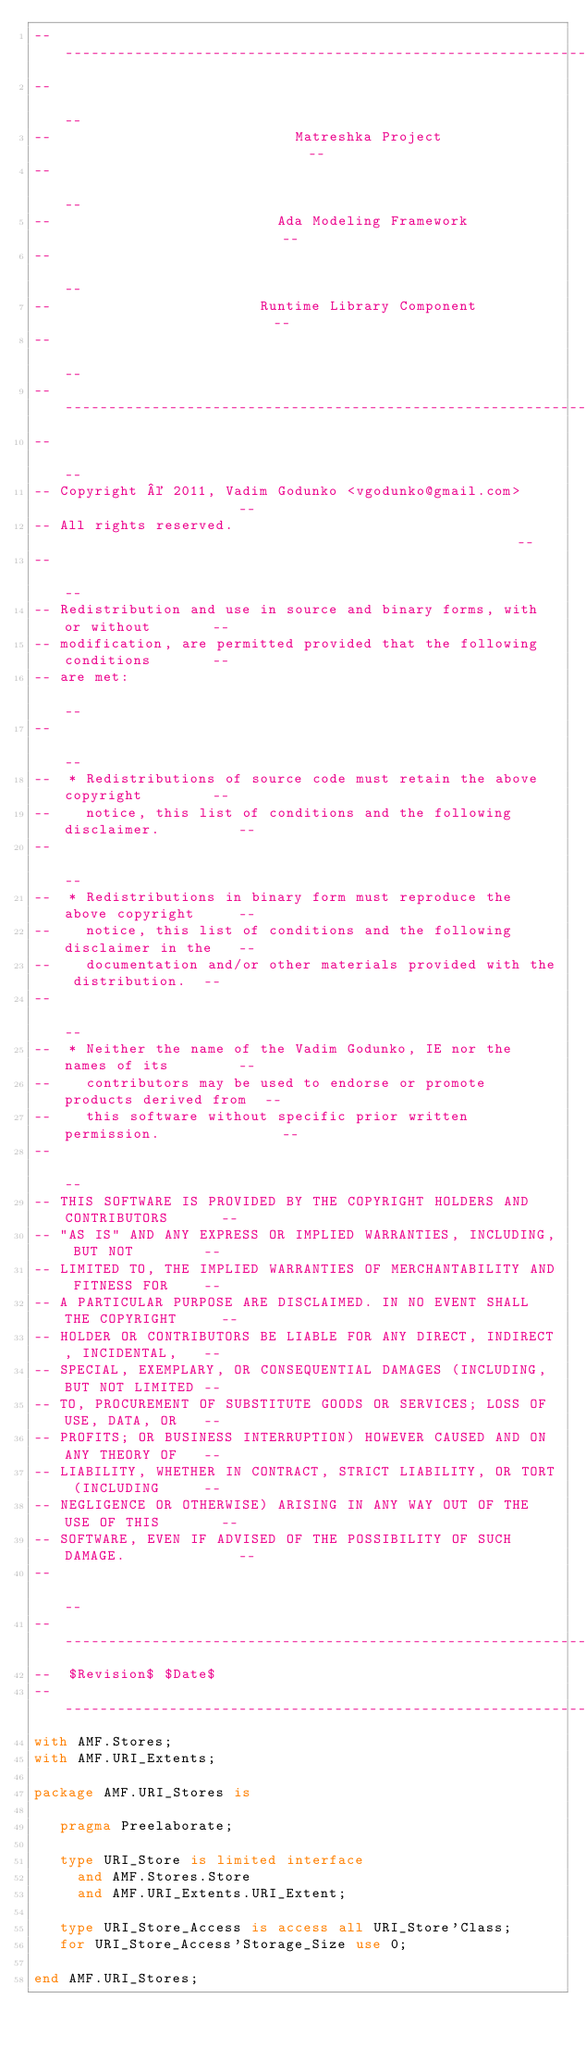Convert code to text. <code><loc_0><loc_0><loc_500><loc_500><_Ada_>------------------------------------------------------------------------------
--                                                                          --
--                            Matreshka Project                             --
--                                                                          --
--                          Ada Modeling Framework                          --
--                                                                          --
--                        Runtime Library Component                         --
--                                                                          --
------------------------------------------------------------------------------
--                                                                          --
-- Copyright © 2011, Vadim Godunko <vgodunko@gmail.com>                     --
-- All rights reserved.                                                     --
--                                                                          --
-- Redistribution and use in source and binary forms, with or without       --
-- modification, are permitted provided that the following conditions       --
-- are met:                                                                 --
--                                                                          --
--  * Redistributions of source code must retain the above copyright        --
--    notice, this list of conditions and the following disclaimer.         --
--                                                                          --
--  * Redistributions in binary form must reproduce the above copyright     --
--    notice, this list of conditions and the following disclaimer in the   --
--    documentation and/or other materials provided with the distribution.  --
--                                                                          --
--  * Neither the name of the Vadim Godunko, IE nor the names of its        --
--    contributors may be used to endorse or promote products derived from  --
--    this software without specific prior written permission.              --
--                                                                          --
-- THIS SOFTWARE IS PROVIDED BY THE COPYRIGHT HOLDERS AND CONTRIBUTORS      --
-- "AS IS" AND ANY EXPRESS OR IMPLIED WARRANTIES, INCLUDING, BUT NOT        --
-- LIMITED TO, THE IMPLIED WARRANTIES OF MERCHANTABILITY AND FITNESS FOR    --
-- A PARTICULAR PURPOSE ARE DISCLAIMED. IN NO EVENT SHALL THE COPYRIGHT     --
-- HOLDER OR CONTRIBUTORS BE LIABLE FOR ANY DIRECT, INDIRECT, INCIDENTAL,   --
-- SPECIAL, EXEMPLARY, OR CONSEQUENTIAL DAMAGES (INCLUDING, BUT NOT LIMITED --
-- TO, PROCUREMENT OF SUBSTITUTE GOODS OR SERVICES; LOSS OF USE, DATA, OR   --
-- PROFITS; OR BUSINESS INTERRUPTION) HOWEVER CAUSED AND ON ANY THEORY OF   --
-- LIABILITY, WHETHER IN CONTRACT, STRICT LIABILITY, OR TORT (INCLUDING     --
-- NEGLIGENCE OR OTHERWISE) ARISING IN ANY WAY OUT OF THE USE OF THIS       --
-- SOFTWARE, EVEN IF ADVISED OF THE POSSIBILITY OF SUCH DAMAGE.             --
--                                                                          --
------------------------------------------------------------------------------
--  $Revision$ $Date$
------------------------------------------------------------------------------
with AMF.Stores;
with AMF.URI_Extents;

package AMF.URI_Stores is

   pragma Preelaborate;

   type URI_Store is limited interface
     and AMF.Stores.Store
     and AMF.URI_Extents.URI_Extent;

   type URI_Store_Access is access all URI_Store'Class;
   for URI_Store_Access'Storage_Size use 0;

end AMF.URI_Stores;
</code> 